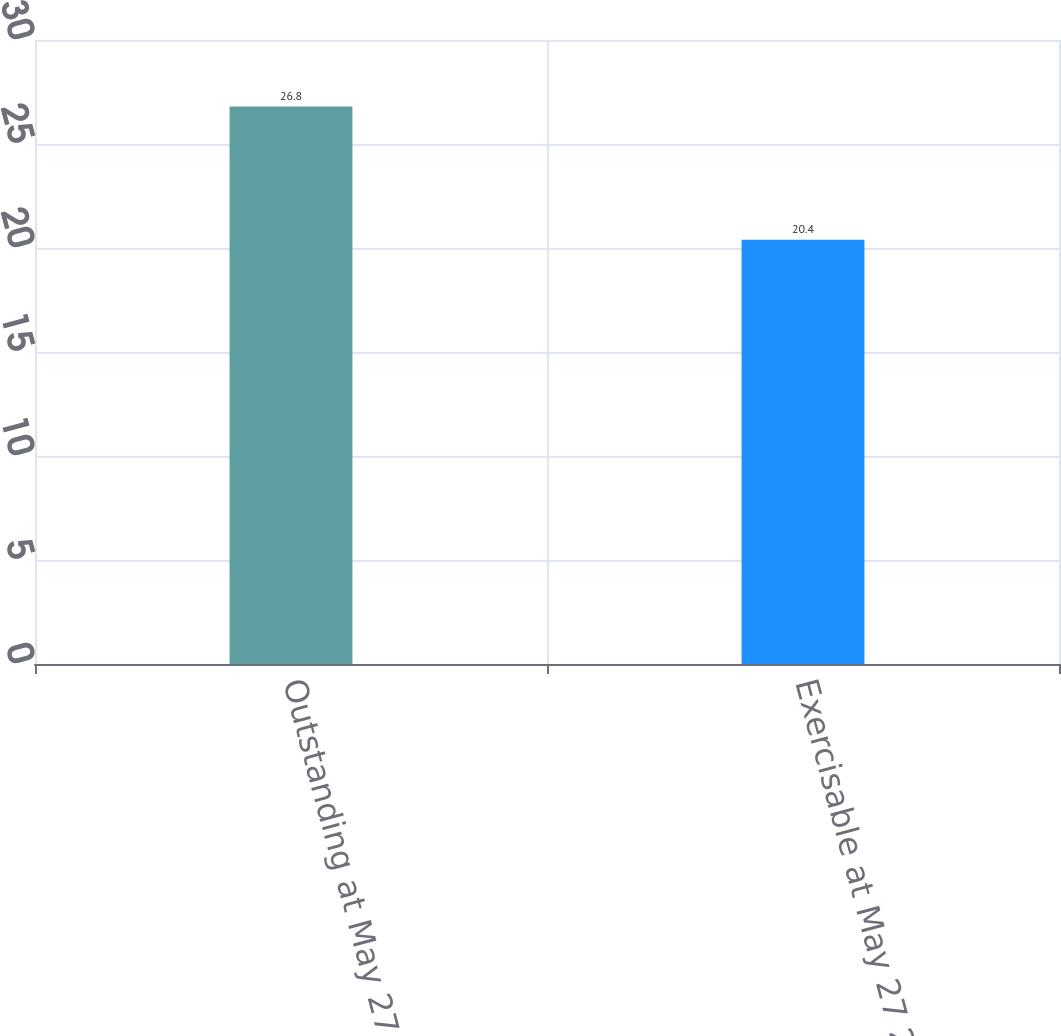Convert chart to OTSL. <chart><loc_0><loc_0><loc_500><loc_500><bar_chart><fcel>Outstanding at May 27 2007<fcel>Exercisable at May 27 2007<nl><fcel>26.8<fcel>20.4<nl></chart> 